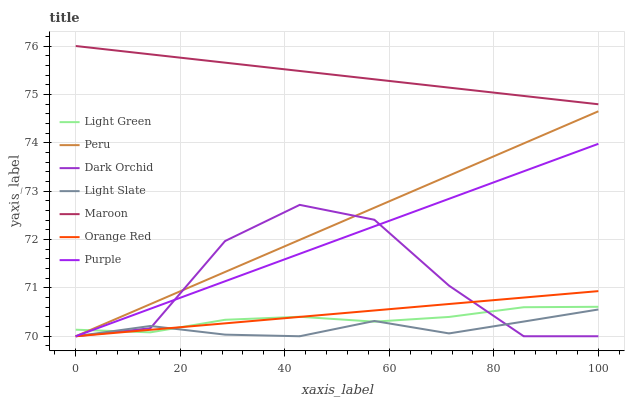Does Light Slate have the minimum area under the curve?
Answer yes or no. Yes. Does Maroon have the maximum area under the curve?
Answer yes or no. Yes. Does Dark Orchid have the minimum area under the curve?
Answer yes or no. No. Does Dark Orchid have the maximum area under the curve?
Answer yes or no. No. Is Purple the smoothest?
Answer yes or no. Yes. Is Dark Orchid the roughest?
Answer yes or no. Yes. Is Light Slate the smoothest?
Answer yes or no. No. Is Light Slate the roughest?
Answer yes or no. No. Does Light Slate have the lowest value?
Answer yes or no. Yes. Does Maroon have the lowest value?
Answer yes or no. No. Does Maroon have the highest value?
Answer yes or no. Yes. Does Dark Orchid have the highest value?
Answer yes or no. No. Is Peru less than Maroon?
Answer yes or no. Yes. Is Maroon greater than Dark Orchid?
Answer yes or no. Yes. Does Light Green intersect Dark Orchid?
Answer yes or no. Yes. Is Light Green less than Dark Orchid?
Answer yes or no. No. Is Light Green greater than Dark Orchid?
Answer yes or no. No. Does Peru intersect Maroon?
Answer yes or no. No. 